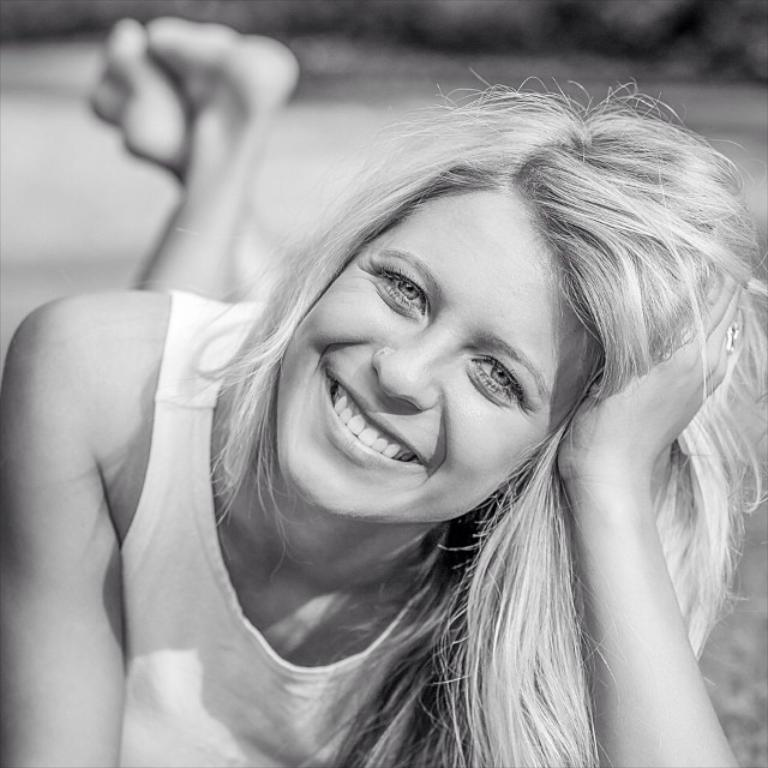What is the main subject of the image? There is a lady lying on the ground in the image. Can you describe the background of the image? The background of the image is blurred. What color mode is the image in? The image is in black and white mode. What type of knee surgery is the lady undergoing in the image? There is no indication of a knee surgery or any medical procedure in the image; it simply shows a lady lying on the ground. What kind of art is the lady creating in the image? There is no art or creative activity being depicted in the image; it only shows a lady lying on the ground. 